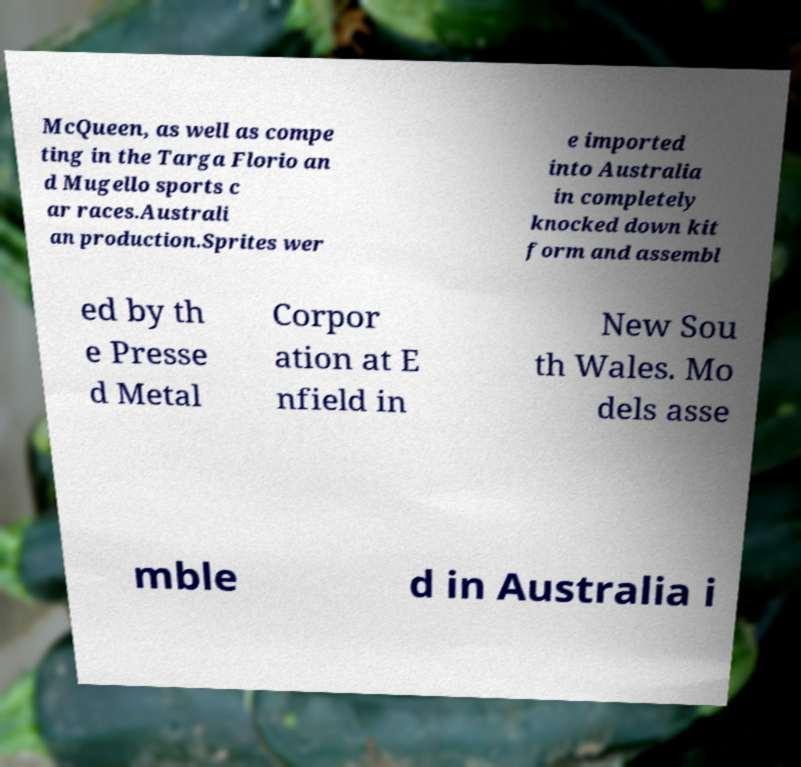There's text embedded in this image that I need extracted. Can you transcribe it verbatim? McQueen, as well as compe ting in the Targa Florio an d Mugello sports c ar races.Australi an production.Sprites wer e imported into Australia in completely knocked down kit form and assembl ed by th e Presse d Metal Corpor ation at E nfield in New Sou th Wales. Mo dels asse mble d in Australia i 